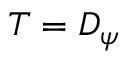<formula> <loc_0><loc_0><loc_500><loc_500>T = D _ { \psi }</formula> 